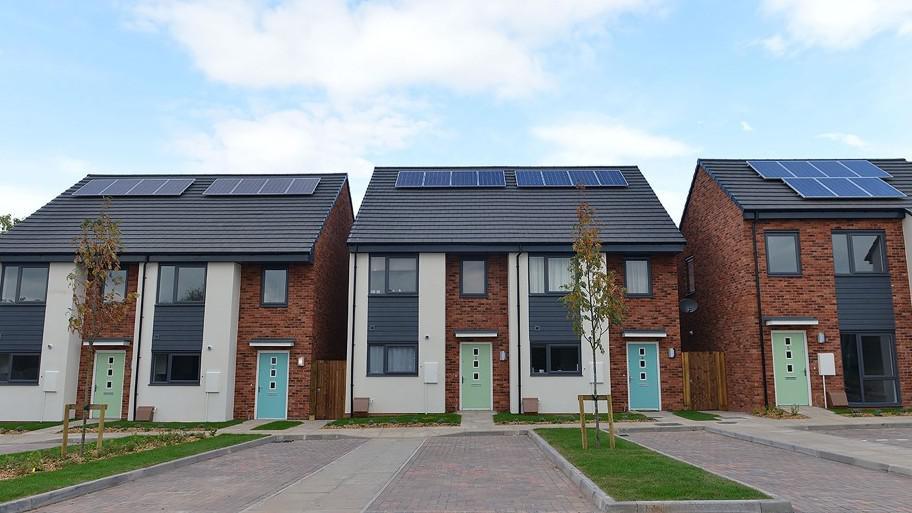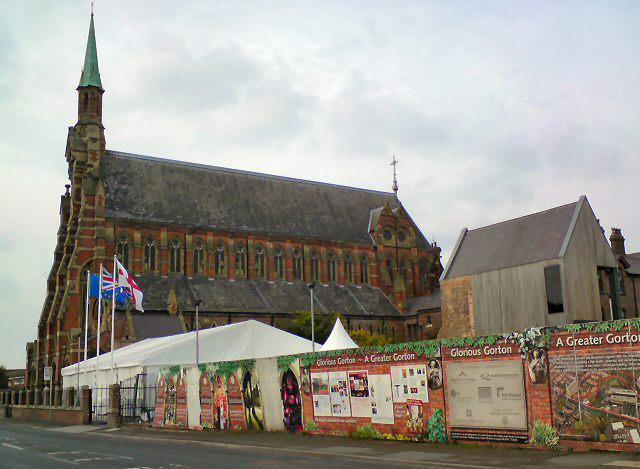The first image is the image on the left, the second image is the image on the right. Evaluate the accuracy of this statement regarding the images: "There is no visible grass in at least one image.". Is it true? Answer yes or no. Yes. 